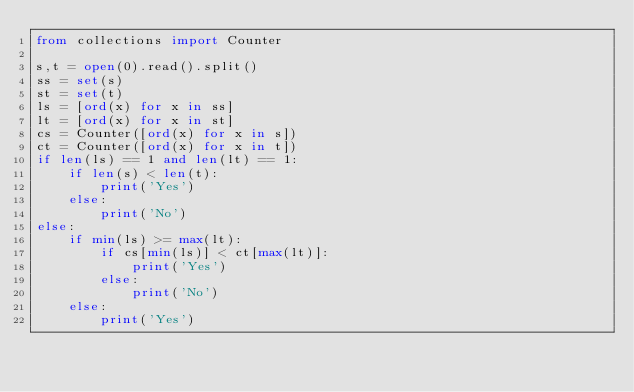<code> <loc_0><loc_0><loc_500><loc_500><_Python_>from collections import Counter

s,t = open(0).read().split()
ss = set(s)
st = set(t)
ls = [ord(x) for x in ss]
lt = [ord(x) for x in st]
cs = Counter([ord(x) for x in s])
ct = Counter([ord(x) for x in t])
if len(ls) == 1 and len(lt) == 1:
    if len(s) < len(t):
        print('Yes')
    else:
        print('No')
else:
    if min(ls) >= max(lt):
        if cs[min(ls)] < ct[max(lt)]:
            print('Yes')
        else:
            print('No')
    else:
        print('Yes')</code> 